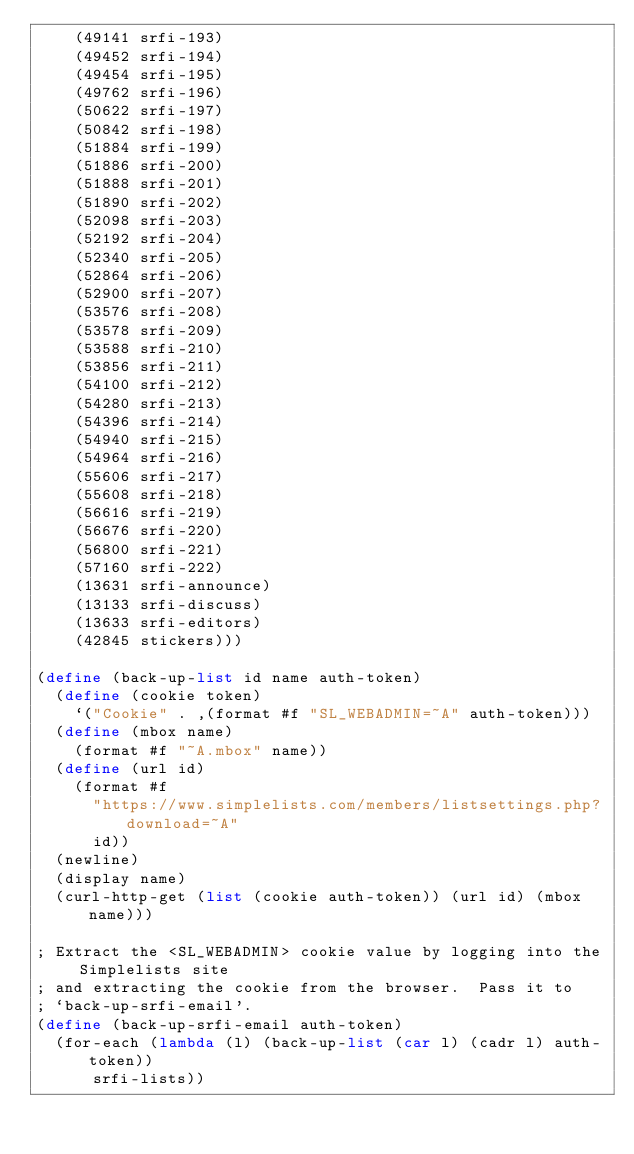<code> <loc_0><loc_0><loc_500><loc_500><_Scheme_>    (49141 srfi-193)
    (49452 srfi-194)
    (49454 srfi-195)
    (49762 srfi-196)
    (50622 srfi-197)
    (50842 srfi-198)
    (51884 srfi-199)
    (51886 srfi-200)
    (51888 srfi-201)
    (51890 srfi-202)
    (52098 srfi-203)
    (52192 srfi-204)
    (52340 srfi-205)
    (52864 srfi-206)
    (52900 srfi-207)
    (53576 srfi-208)
    (53578 srfi-209)
    (53588 srfi-210)
    (53856 srfi-211)
    (54100 srfi-212)
    (54280 srfi-213)
    (54396 srfi-214)
    (54940 srfi-215)
    (54964 srfi-216)
    (55606 srfi-217)
    (55608 srfi-218)
    (56616 srfi-219)
    (56676 srfi-220)
    (56800 srfi-221)
    (57160 srfi-222)
    (13631 srfi-announce)
    (13133 srfi-discuss)
    (13633 srfi-editors)
    (42845 stickers)))

(define (back-up-list id name auth-token)
  (define (cookie token)
    `("Cookie" . ,(format #f "SL_WEBADMIN=~A" auth-token)))
  (define (mbox name)
    (format #f "~A.mbox" name))
  (define (url id)
    (format #f
	    "https://www.simplelists.com/members/listsettings.php?download=~A"
	    id))
  (newline)
  (display name)
  (curl-http-get (list (cookie auth-token)) (url id) (mbox name)))

; Extract the <SL_WEBADMIN> cookie value by logging into the Simplelists site
; and extracting the cookie from the browser.  Pass it to
; `back-up-srfi-email'.
(define (back-up-srfi-email auth-token)
  (for-each (lambda (l) (back-up-list (car l) (cadr l) auth-token))
	    srfi-lists))</code> 